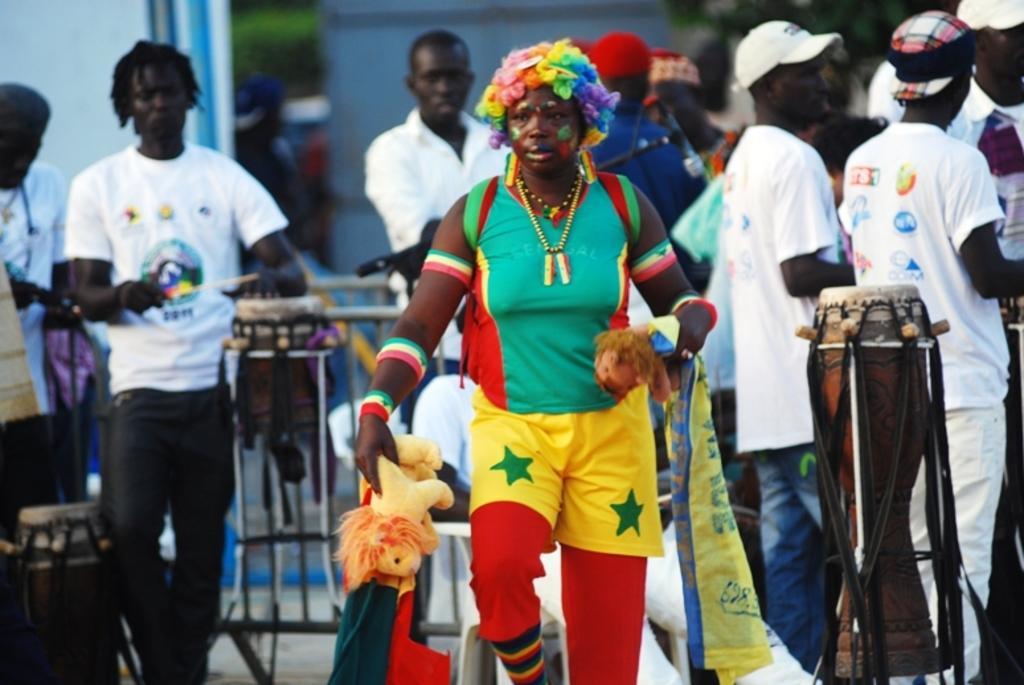How would you summarize this image in a sentence or two? In the image we can see there are people who are standing on the road. 